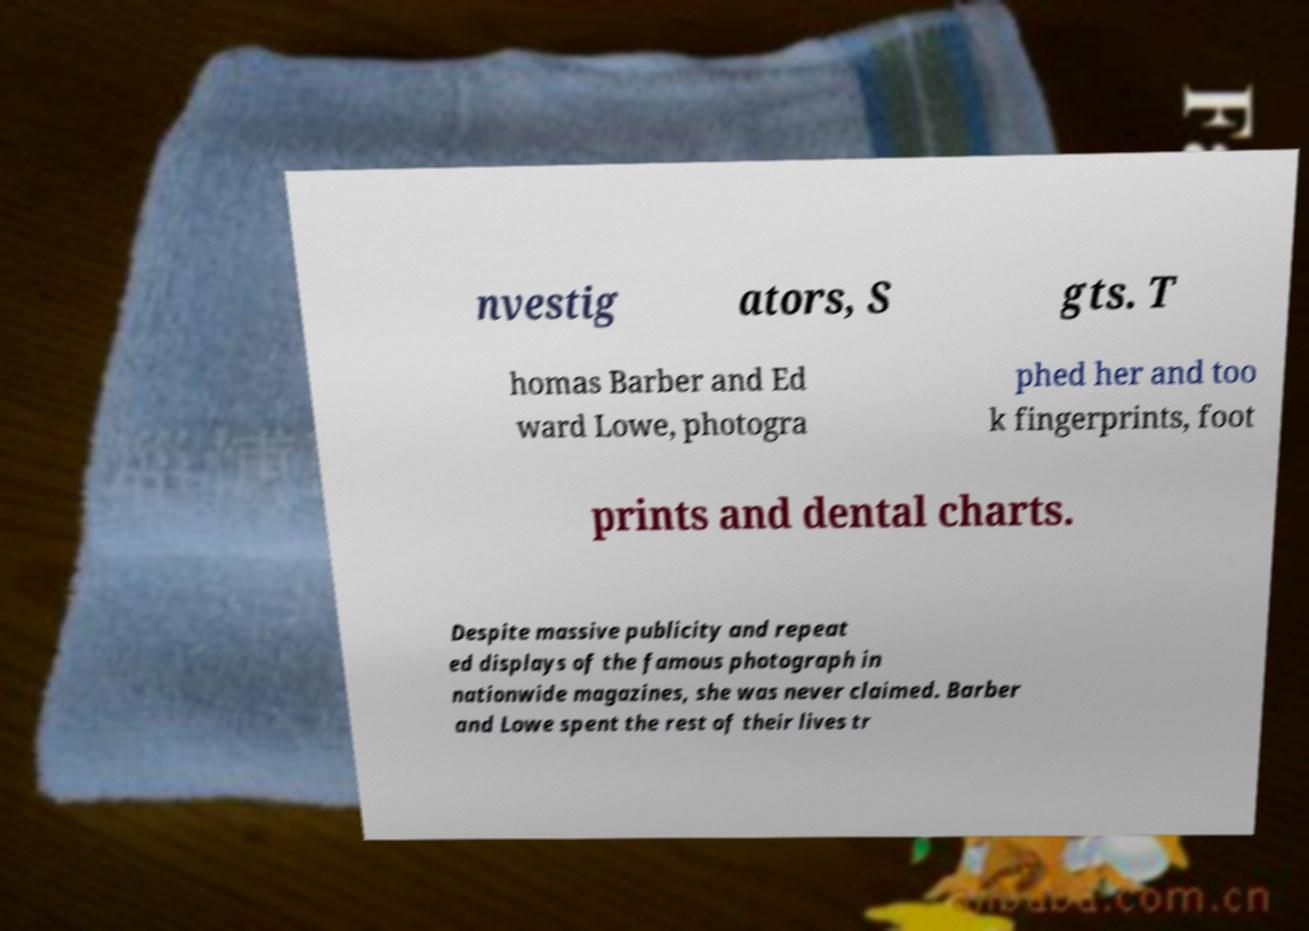Could you extract and type out the text from this image? nvestig ators, S gts. T homas Barber and Ed ward Lowe, photogra phed her and too k fingerprints, foot prints and dental charts. Despite massive publicity and repeat ed displays of the famous photograph in nationwide magazines, she was never claimed. Barber and Lowe spent the rest of their lives tr 